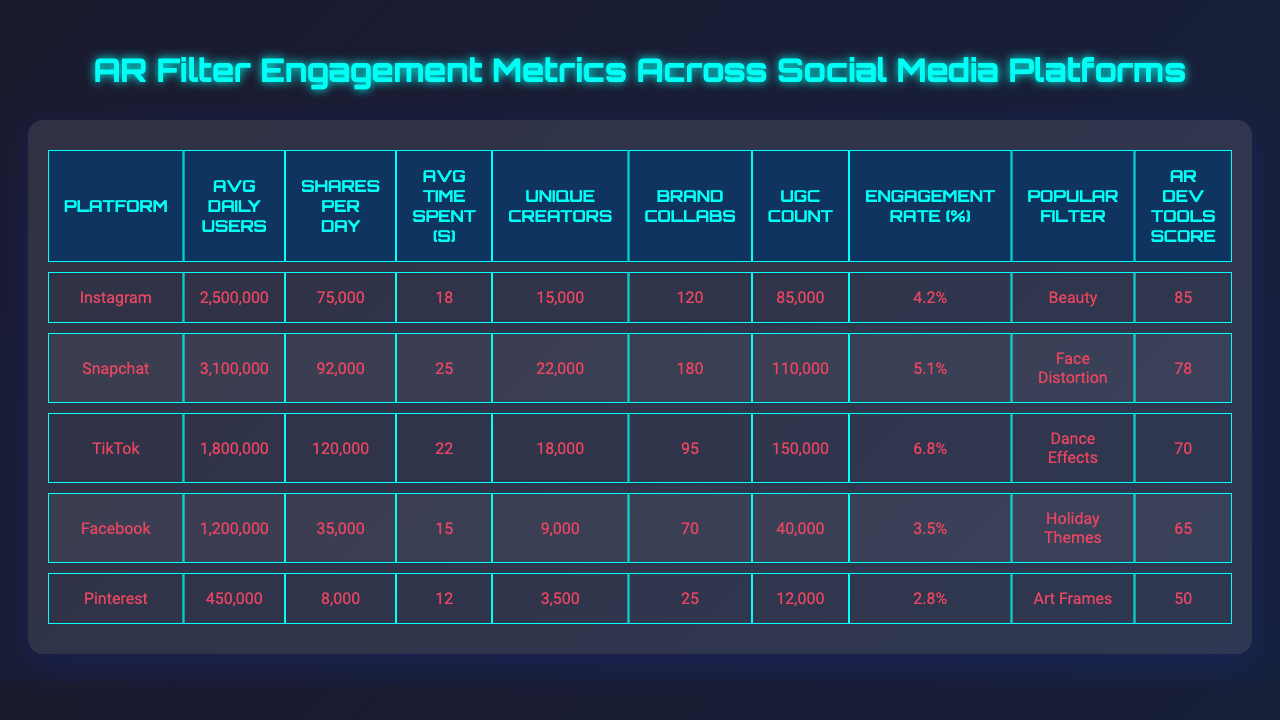What platform has the highest average daily users? By looking at the "Avg Daily Users" column, Instagram has 2,500,000 users, which is higher than all other platforms listed in the table.
Answer: Instagram What is the engagement rate on TikTok? The "Engagement Rate (%)" for TikTok is listed as 6.8%, which can be directly found in the corresponding column.
Answer: 6.8% Which platform has the lowest user-generated content count? When reviewing the "UGC Count" column, Pinterest shows a total of 12,000, which is the smallest value compared to other platforms.
Answer: Pinterest How many shares per day does Snapchat receive? Referring to the "Shares Per Day" column, Snapchat has 92,000 shares per day.
Answer: 92,000 What is the average time spent per use on Facebook? The "Avg Time Spent (s)" for Facebook is noted as 15 seconds in the table.
Answer: 15 seconds Which platform has more unique creators, Facebook or Pinterest? Facebook has 9,000 unique creators while Pinterest has 3,500 unique creators, making Facebook the platform with more creators.
Answer: Facebook What is the difference in average daily users between Instagram and Facebook? Instagram has 2,500,000 daily users while Facebook has 1,200,000. The difference is calculated as 2,500,000 - 1,200,000 = 1,300,000.
Answer: 1,300,000 Which platform has the highest brand collaborations? Looking at the "Brand Collabs" column, Snapchat has the highest number with a total of 180 collaborations.
Answer: Snapchat Are there more average shares per day on TikTok than on Instagram? TikTok has 120,000 shares per day, while Instagram has 75,000. This shows that TikTok has more shares per day than Instagram.
Answer: Yes What is the combined total of average daily users for Instagram and Snapchat? By adding the average daily users, Instagram has 2,500,000 and Snapchat has 3,100,000, resulting in 2,500,000 + 3,100,000 = 5,600,000 users combined.
Answer: 5,600,000 Which platform has the most popular filter category "Beauty"? The table indicates that "Beauty" is the most popular filter category on Instagram.
Answer: Instagram Is the average engagement rate on Pinterest higher than that on Facebook? Pinterest has an engagement rate of 2.8%, while Facebook's is 3.5%. Hence, Pinterest's engagement rate is lower.
Answer: No What is the average engagement rate for all platforms? To find the average, add up all engagement rates: (4.2 + 5.1 + 6.8 + 3.5 + 2.8) = 22.4%, then divide by the number of platforms (5), resulting in an average of 22.4% / 5 = 4.48%.
Answer: 4.48% 